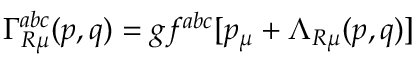Convert formula to latex. <formula><loc_0><loc_0><loc_500><loc_500>\Gamma _ { R \mu } ^ { a b c } ( p , q ) = g f ^ { a b c } [ p _ { \mu } + \Lambda _ { R \mu } ( p , q ) ]</formula> 